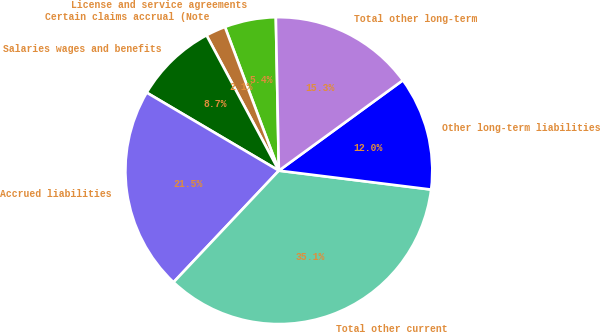<chart> <loc_0><loc_0><loc_500><loc_500><pie_chart><fcel>License and service agreements<fcel>Certain claims accrual (Note<fcel>Salaries wages and benefits<fcel>Accrued liabilities<fcel>Total other current<fcel>Other long-term liabilities<fcel>Total other long-term<nl><fcel>5.4%<fcel>2.1%<fcel>8.7%<fcel>21.45%<fcel>35.07%<fcel>11.99%<fcel>15.29%<nl></chart> 